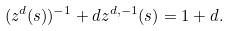<formula> <loc_0><loc_0><loc_500><loc_500>( z ^ { d } ( s ) ) ^ { - 1 } + d z ^ { d , - 1 } ( s ) = 1 + d .</formula> 